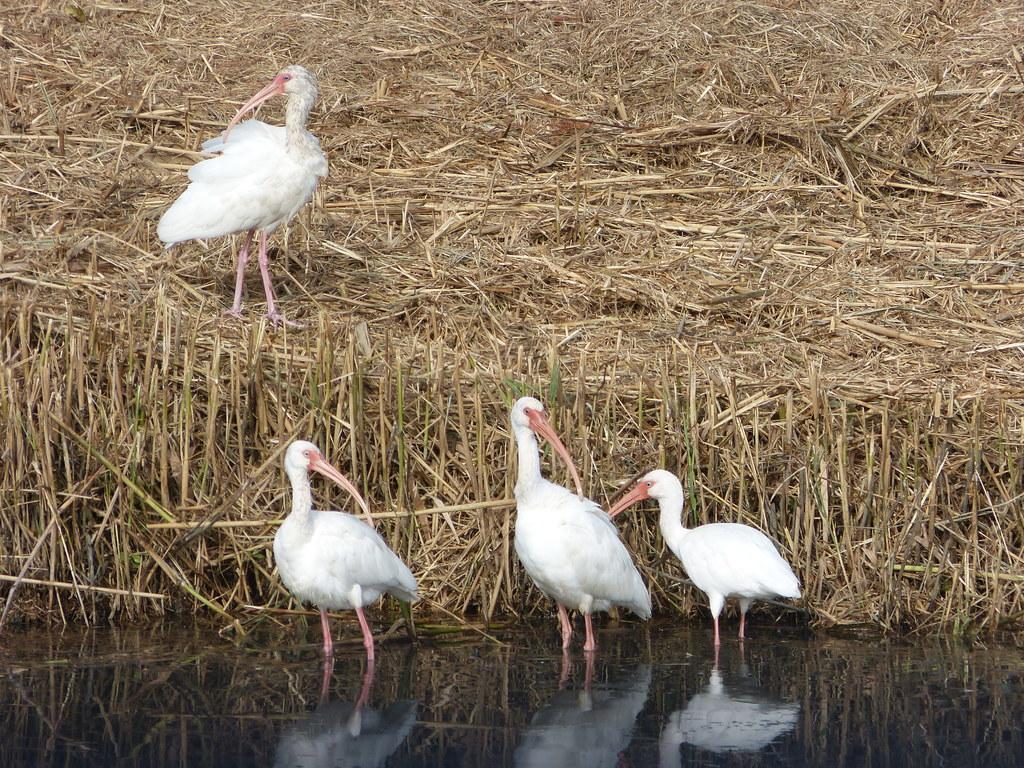Can you describe this image briefly? In this image in the front there are birds standing in the water. In the background there is dry grass and on the dry grass there is a bird standing. 